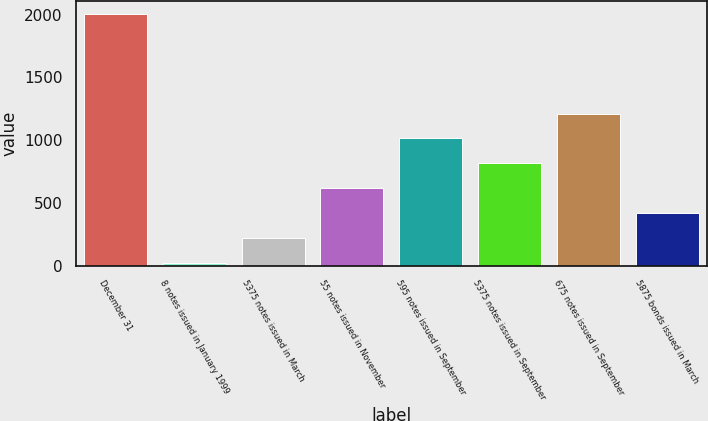Convert chart. <chart><loc_0><loc_0><loc_500><loc_500><bar_chart><fcel>December 31<fcel>8 notes issued in January 1999<fcel>5375 notes issued in March<fcel>55 notes issued in November<fcel>595 notes issued in September<fcel>5375 notes issued in September<fcel>675 notes issued in September<fcel>5875 bonds issued in March<nl><fcel>2007<fcel>20<fcel>218.7<fcel>616.1<fcel>1013.5<fcel>814.8<fcel>1212.2<fcel>417.4<nl></chart> 